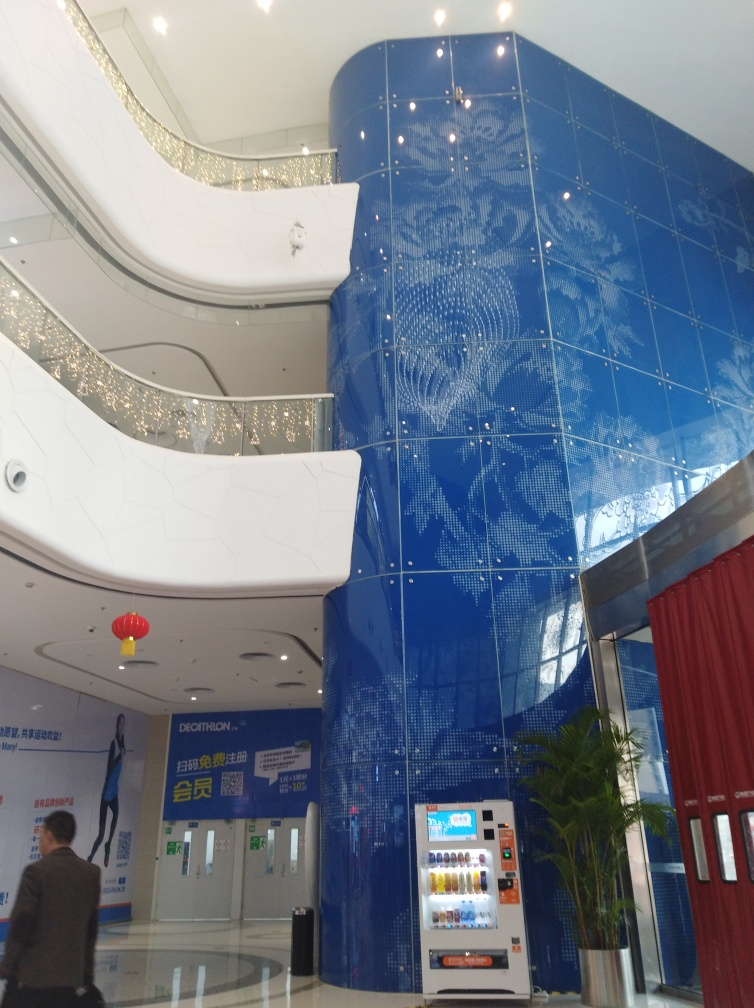Can you describe the mosaic design on the wall? The mosaic design on the wall features intricate patterns that evoke a sense of fluidity and motion, reminiscent of stylized waves or ripples. The use of different shades of blue tiles gives the artwork depth and dimension, creating an engaging visual effect that becomes the centerpiece of the interior architecture. 